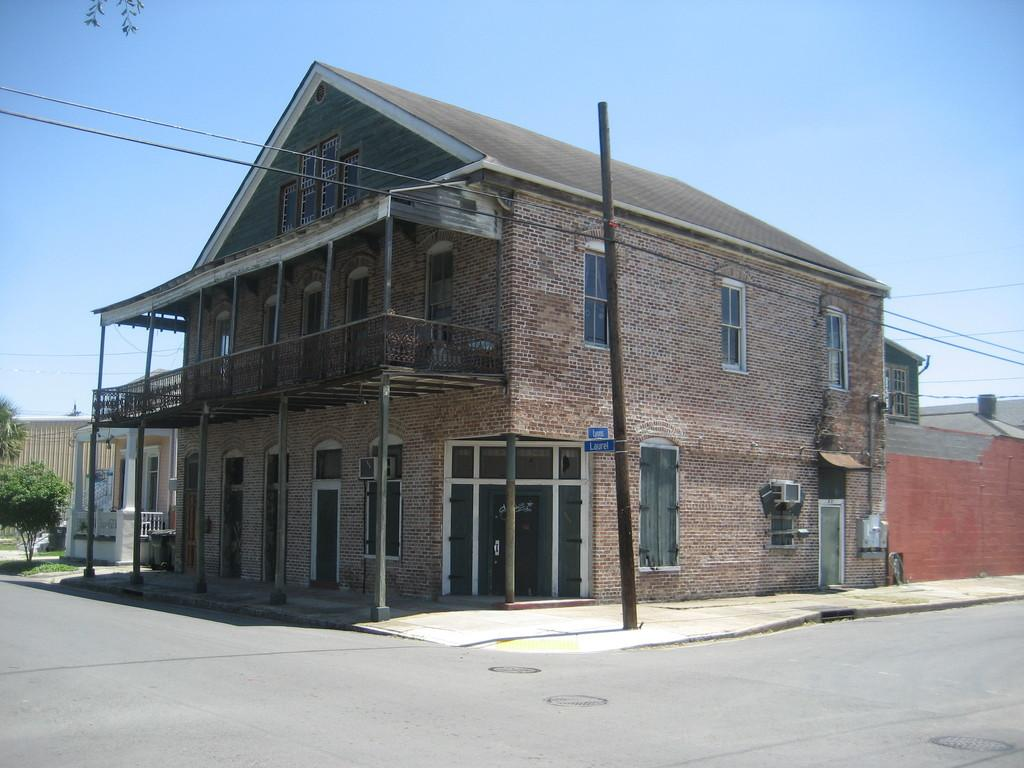What type of structure is in the image? There is a big house in the image. What can be seen in the center of the image? There is a pole in the center of the image. What type of vegetation is on the left side of the image? There are plants on the left side of the image. Reasoning: Let' Let's think step by step in order to produce the conversation. We start by identifying the main subject in the image, which is the big house. Then, we expand the conversation to include other items that are also visible, such as the pole and the plants. Each question is designed to elicit a specific detail about the image that is known from the provided facts. Absurd Question/Answer: What type of lettuce is growing on the pole in the image? There is no lettuce present in the image; it features a big house, a pole, and plants. Who is the representative of the house in the image? The image does not depict any people or representatives; it only shows a big house, a pole, and plants. 